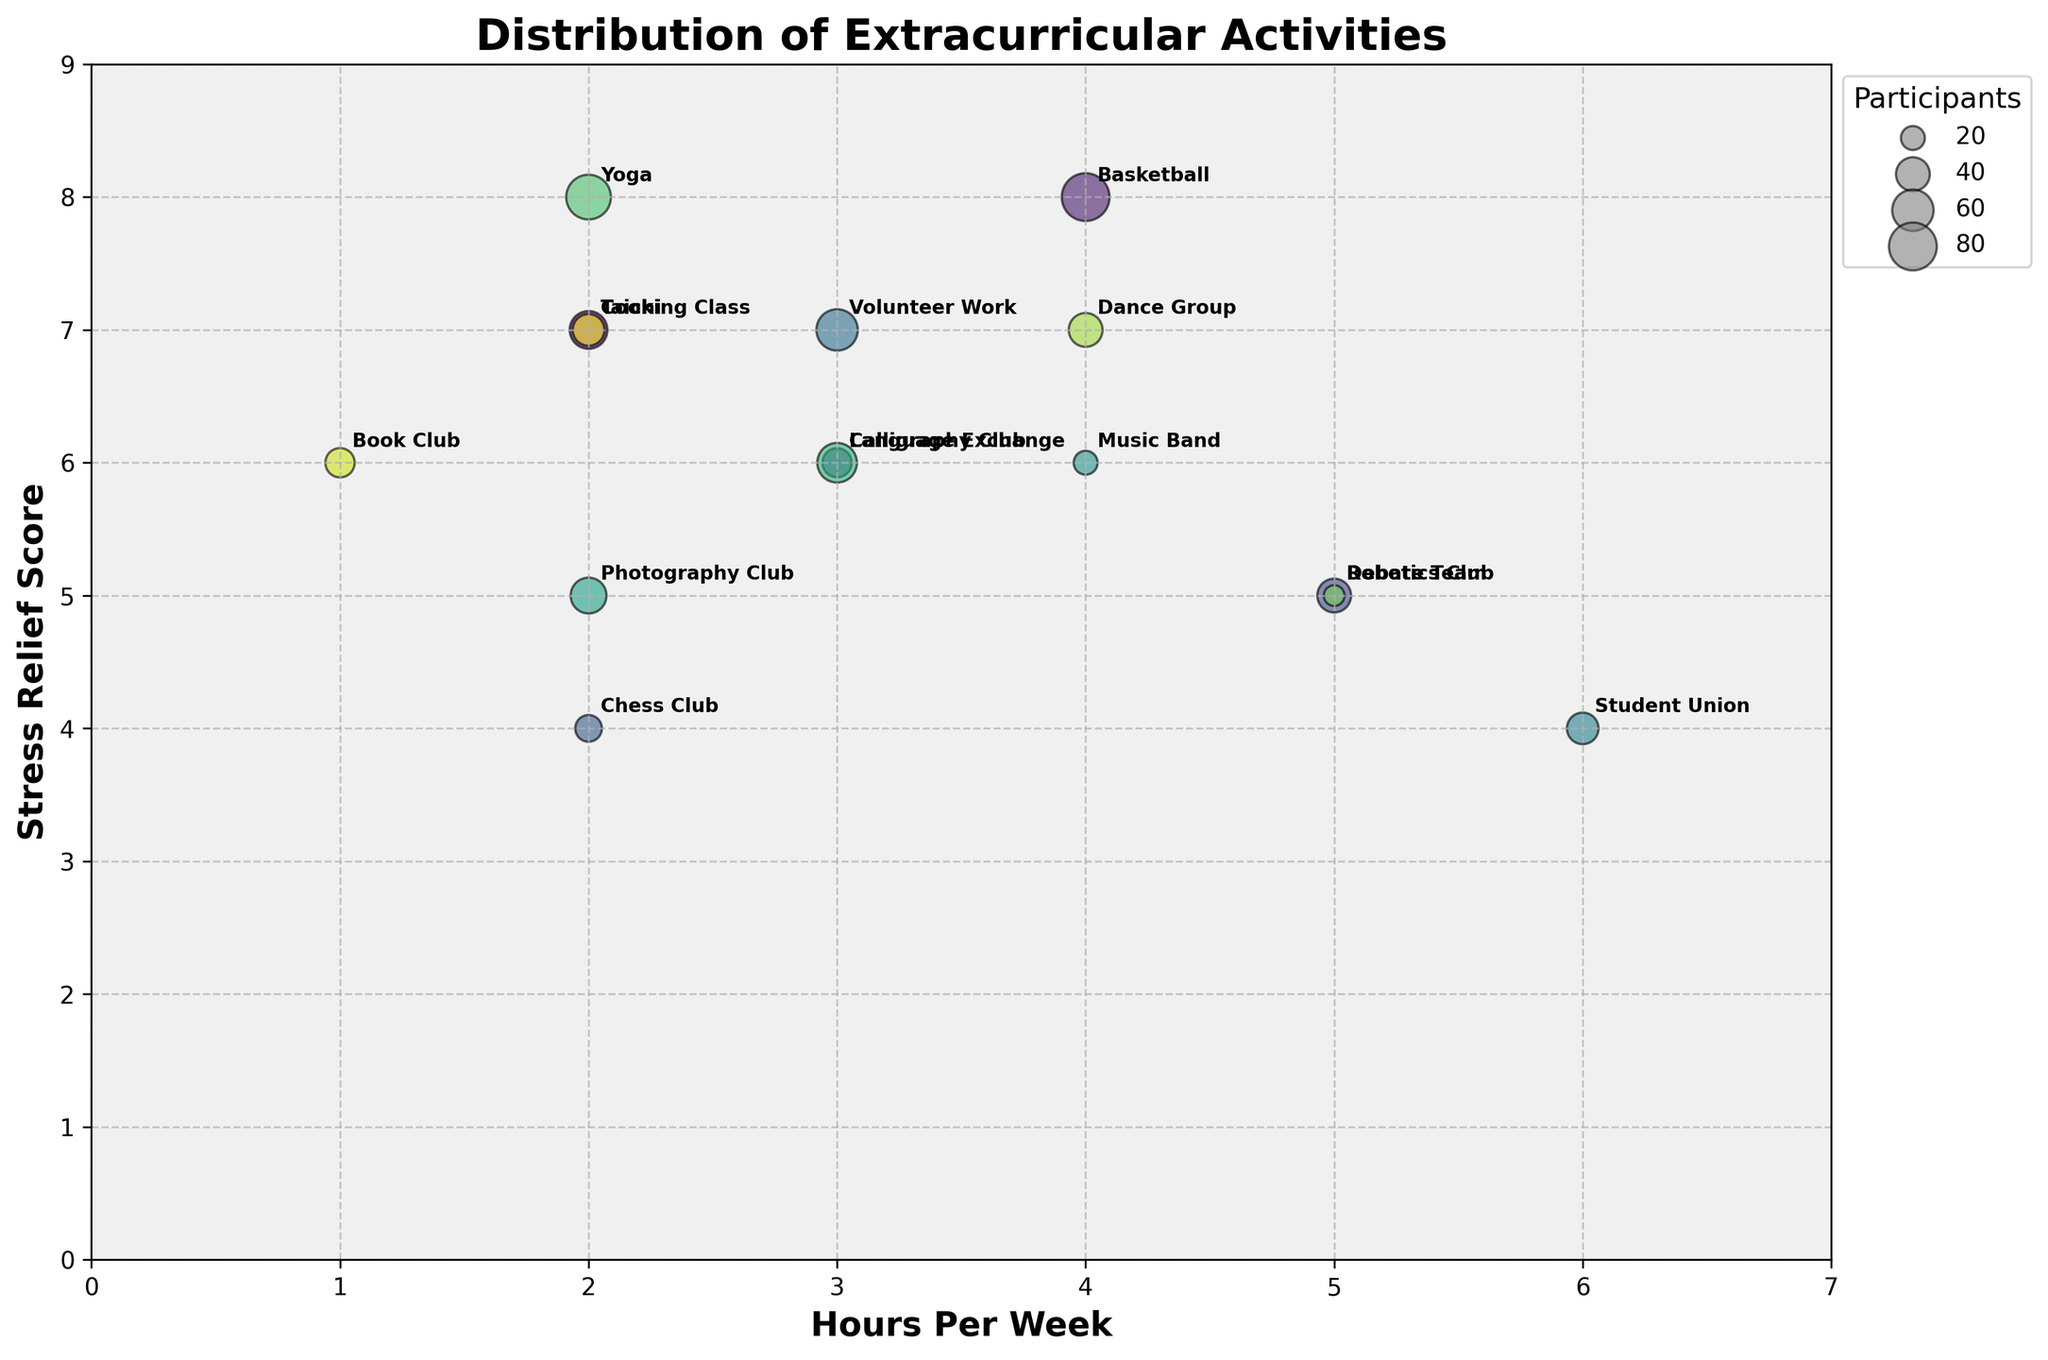How many activities have a stress relief score of 7? First, we look at the y-axis labeled "Stress Relief Score" to find where it equals 7. Then, we count the number of bubbles that are positioned at this score. The activities are Taichi, Volunteer Work, Dance Group, and Cooking Class.
Answer: 4 Which activity requires the highest time commitment per week? To find this, locate the activity with the largest x-value on the "Hours Per Week" axis. The Student Union has the highest time commitment, at 6 hours per week.
Answer: Student Union Which activity appears to offer the best stress relief? We look for the activity with the highest y-value on the "Stress Relief Score" axis. Yoga has the highest score of 8.
Answer: Yoga Among activities that have 4 or more participants, which has the lowest perceived stress relief score? First, identify the activities that have 4 or more participants. Then, find the one with the lowest y-value (Stress Relief Score). The activity is the Student Union with a score of 4.
Answer: Student Union What is the total number of participants in all activities? Add the number of participants for all activities: 50 (Taichi) + 80 (Basketball) + 30 (Calligraphy Club) + 40 (Debate Team) + 25 (Chess Club) + 60 (Volunteer Work) + 35 (Student Union) + 20 (Music Band) + 45 (Photography Club) + 55 (Language Exchange) + 70 (Yoga) + 15 (Robotics Club) + 40 (Dance Group) + 30 (Book Club) + 35 (Cooking Class).
Answer: 630 Which activity has the largest number of participants but offers medium stress relief? Locate the activity with the largest bubble size and a medium y-value between 4 and 6. Basketball has the largest number of participants (80) with a stress relief score of 8. However, Calligraphy Club with 6 stress relief and 30 participants is medium.
Answer: Calligraphy Club How does the stress relief provided by Yoga compare to that of Chess Club? Check both activities on the y-axis: Yoga has a stress relief score of 8, while Chess Club has a score of 4. Yoga offers a higher stress relief compared to Chess Club.
Answer: Yoga What is the average time commitment for activities with a stress relief score of 6? Identify the activities with a stress relief score of 6: Calligraphy Club, Music Band, Language Exchange, Book Club. Add their weekly hours: 3 + 4 + 3 + 1 = 11. Divide by the number of activities (4): 11/4 = 2.75.
Answer: 2.75 Which activity with the lowest time commitment offers the best stress relief? Find the activities with the lowest time commitment (1 hour per week): Book Club. It offers a stress relief score of 6, which is the highest among activities with the lowest time commitment.
Answer: Book Club 